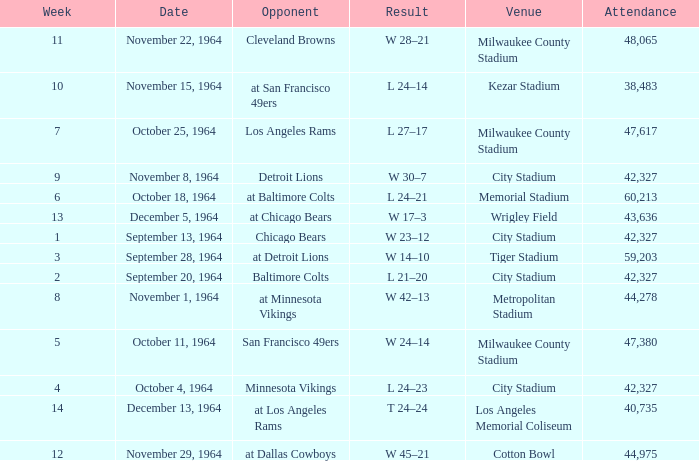What is the average attendance at a week 4 game? 42327.0. 